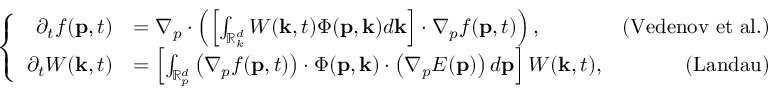Convert formula to latex. <formula><loc_0><loc_0><loc_500><loc_500>\left \{ \begin{array} { r l r } { \partial _ { t } f ( p , t ) } & { = \nabla _ { p } \cdot \left ( \left [ \int _ { \mathbb { R } _ { k } ^ { d } } W ( k , t ) \Phi ( p , k ) d k \right ] \cdot \nabla _ { p } f ( p , t ) \right ) , } & { ( V e d e n o v e t a l . ) } \\ { \partial _ { t } W ( k , t ) } & { = \left [ \int _ { \mathbb { R } _ { p } ^ { d } } \left ( \nabla _ { p } f ( p , t ) \right ) \cdot \Phi ( p , k ) \cdot \left ( \nabla _ { p } E ( p ) \right ) d p \right ] W ( k , t ) , } & { ( L a n d a u ) } \end{array}</formula> 